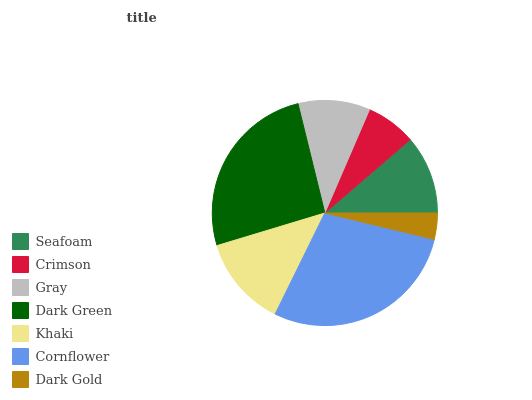Is Dark Gold the minimum?
Answer yes or no. Yes. Is Cornflower the maximum?
Answer yes or no. Yes. Is Crimson the minimum?
Answer yes or no. No. Is Crimson the maximum?
Answer yes or no. No. Is Seafoam greater than Crimson?
Answer yes or no. Yes. Is Crimson less than Seafoam?
Answer yes or no. Yes. Is Crimson greater than Seafoam?
Answer yes or no. No. Is Seafoam less than Crimson?
Answer yes or no. No. Is Seafoam the high median?
Answer yes or no. Yes. Is Seafoam the low median?
Answer yes or no. Yes. Is Dark Green the high median?
Answer yes or no. No. Is Cornflower the low median?
Answer yes or no. No. 